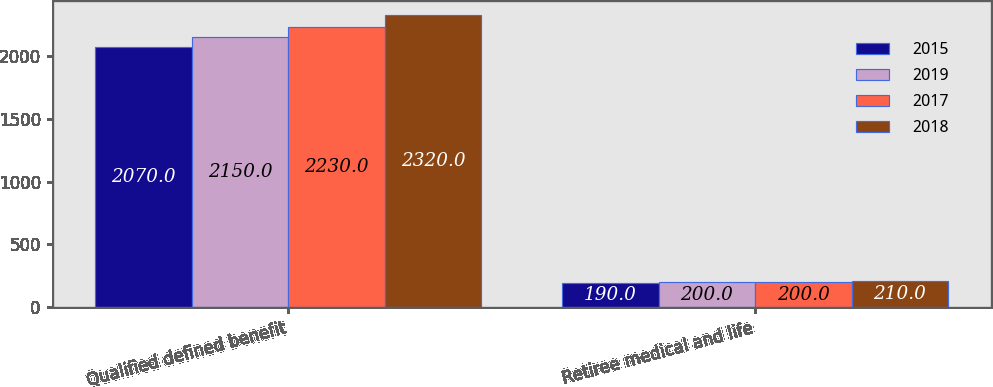Convert chart. <chart><loc_0><loc_0><loc_500><loc_500><stacked_bar_chart><ecel><fcel>Qualified defined benefit<fcel>Retiree medical and life<nl><fcel>2015<fcel>2070<fcel>190<nl><fcel>2019<fcel>2150<fcel>200<nl><fcel>2017<fcel>2230<fcel>200<nl><fcel>2018<fcel>2320<fcel>210<nl></chart> 